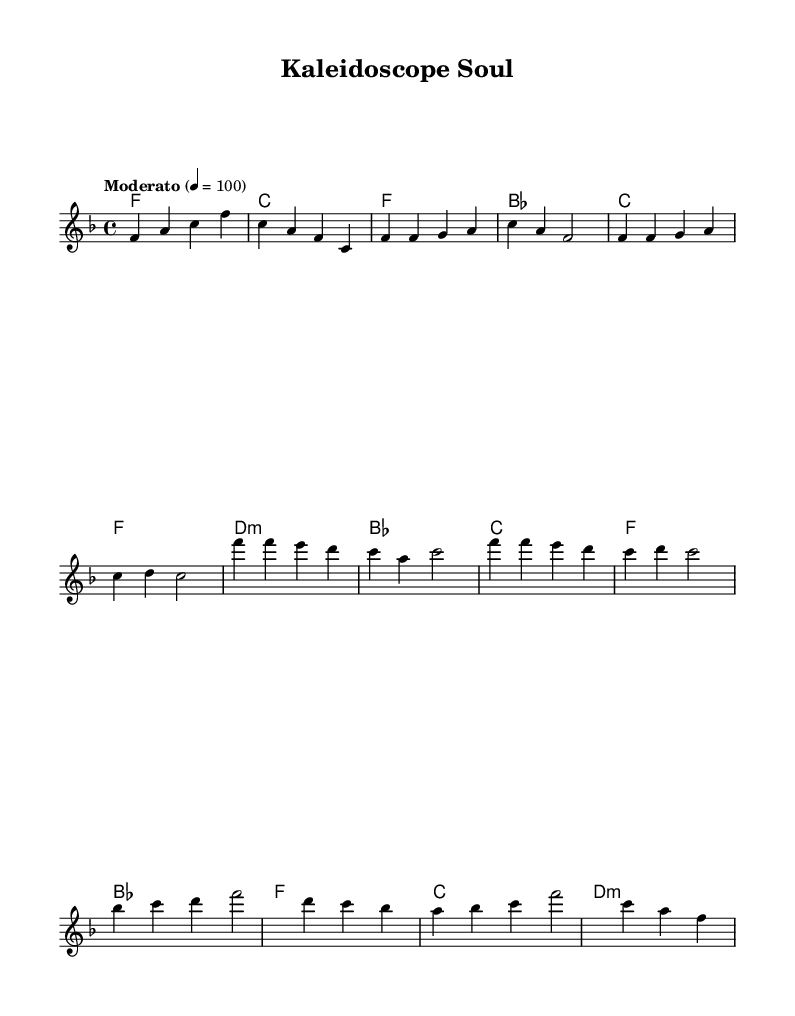What is the key signature of this music? The key signature is F major, which has one flat (B flat). In the sheet music, the key signature is indicated at the beginning, showing the B flat symbol.
Answer: F major What is the time signature of the music? The time signature is 4/4, which means there are four beats in each measure, and the quarter note gets one beat. This is shown in the sheet music right after the key signature.
Answer: 4/4 What is the tempo marking for this piece? The tempo marking states "Moderato" with a metronome marking of 100 beats per minute. In the sheet music, this indicates a moderate speed for the performance.
Answer: Moderato 100 How many measures are in the chorus section of the music? The chorus contains four measures. By counting the measures indicated in the sheet music, there are four distinct groups of notes for this section.
Answer: 4 What is the first note of the bridge? The first note of the bridge is B flat, which is highlighted in the melody section of the music. The bridge starts with the notes shown after the chorus.
Answer: B flat What type of chord is used in the chorus? The chorus features a D minor chord, indicated by the "d:m" notation in the harmonies. This is a specific chord type commonly used in contemporary R&B genres.
Answer: D minor What thematic element does the title "Kaleidoscope Soul" suggest about the music? The title suggests a celebration of mixed-race identity and heritage, as a "kaleidoscope" implies diversity and richness in cultural background, reflecting the themes often explored in contemporary R&B.
Answer: Diversity 